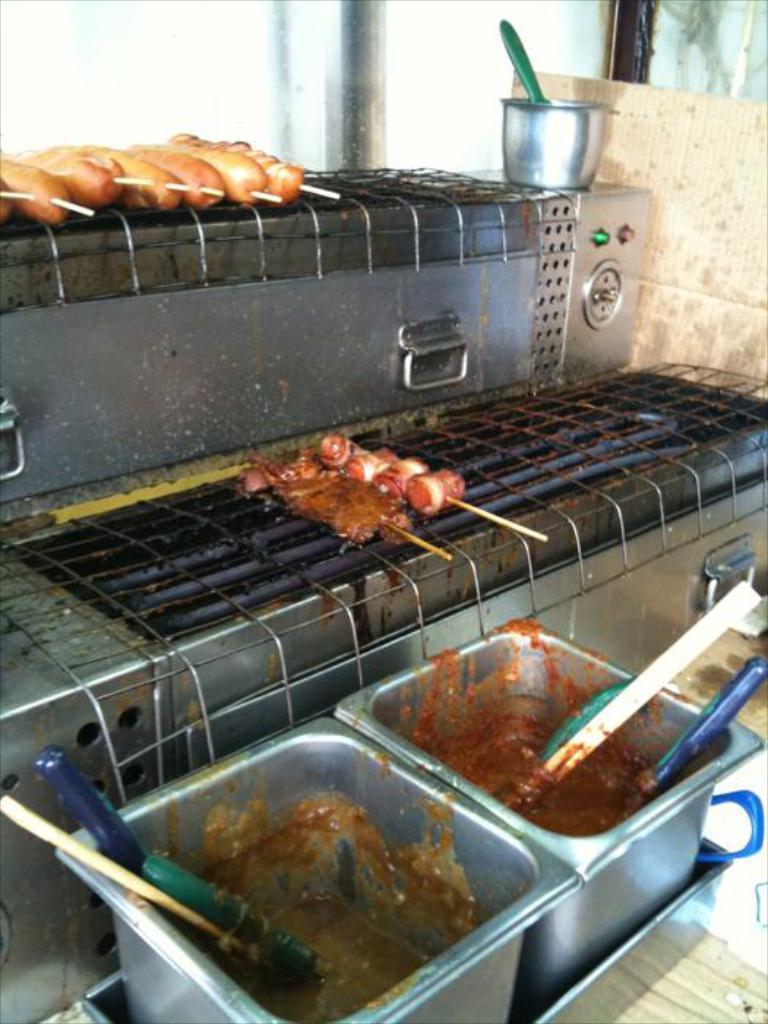Please provide a concise description of this image. In this picture I can observe some food placed on the grills. There are two bowls in front of the grills. In the background I can observe a glass. 